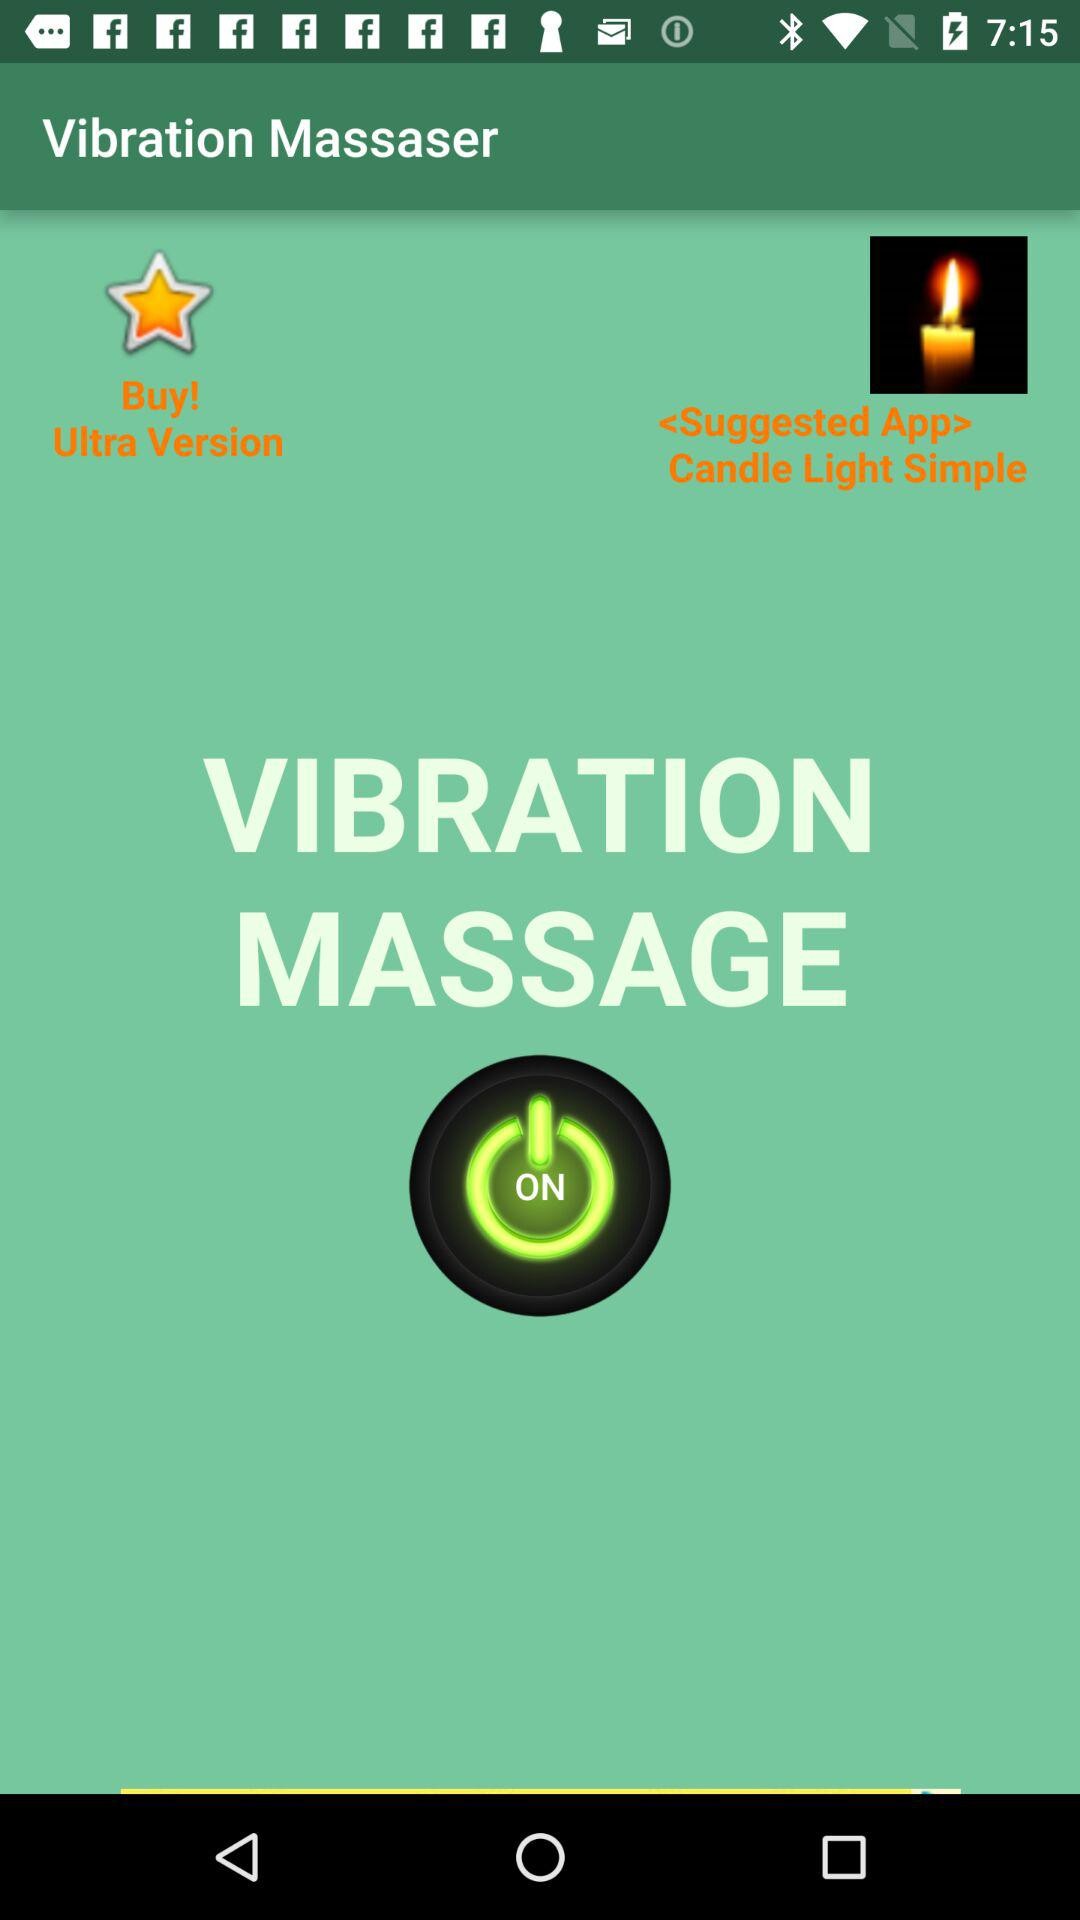What is the app name? The app name is "Vibration Massaser". 